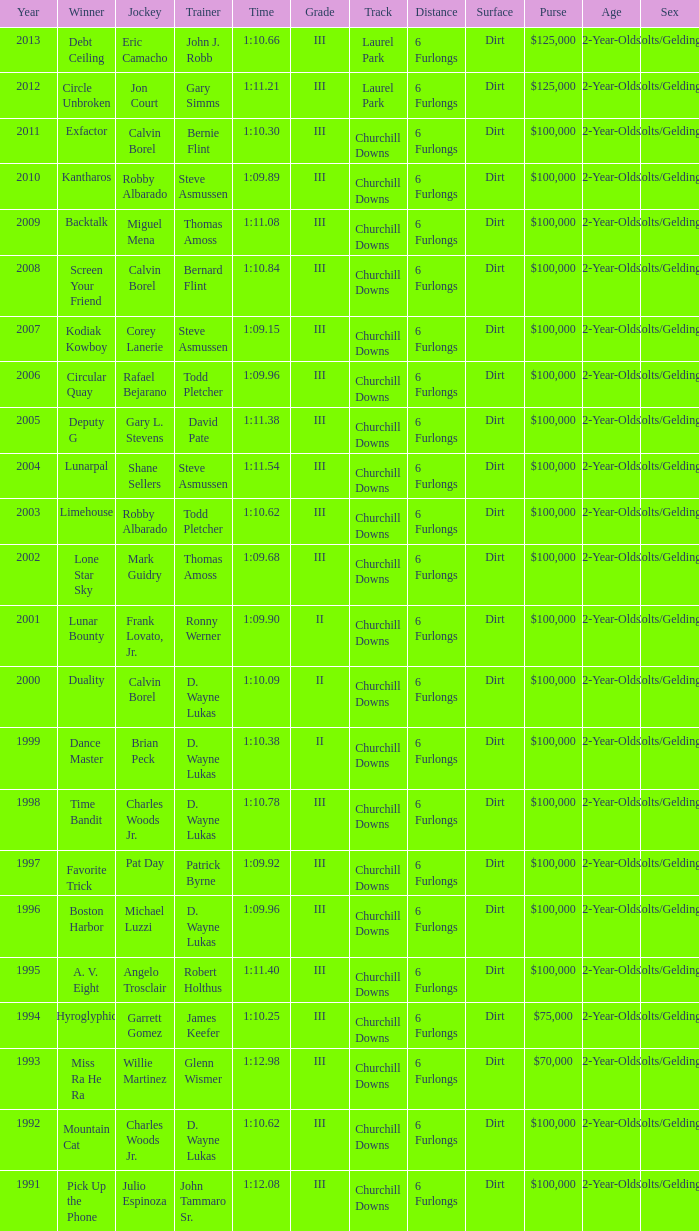What was the time for Screen Your Friend? 1:10.84. 